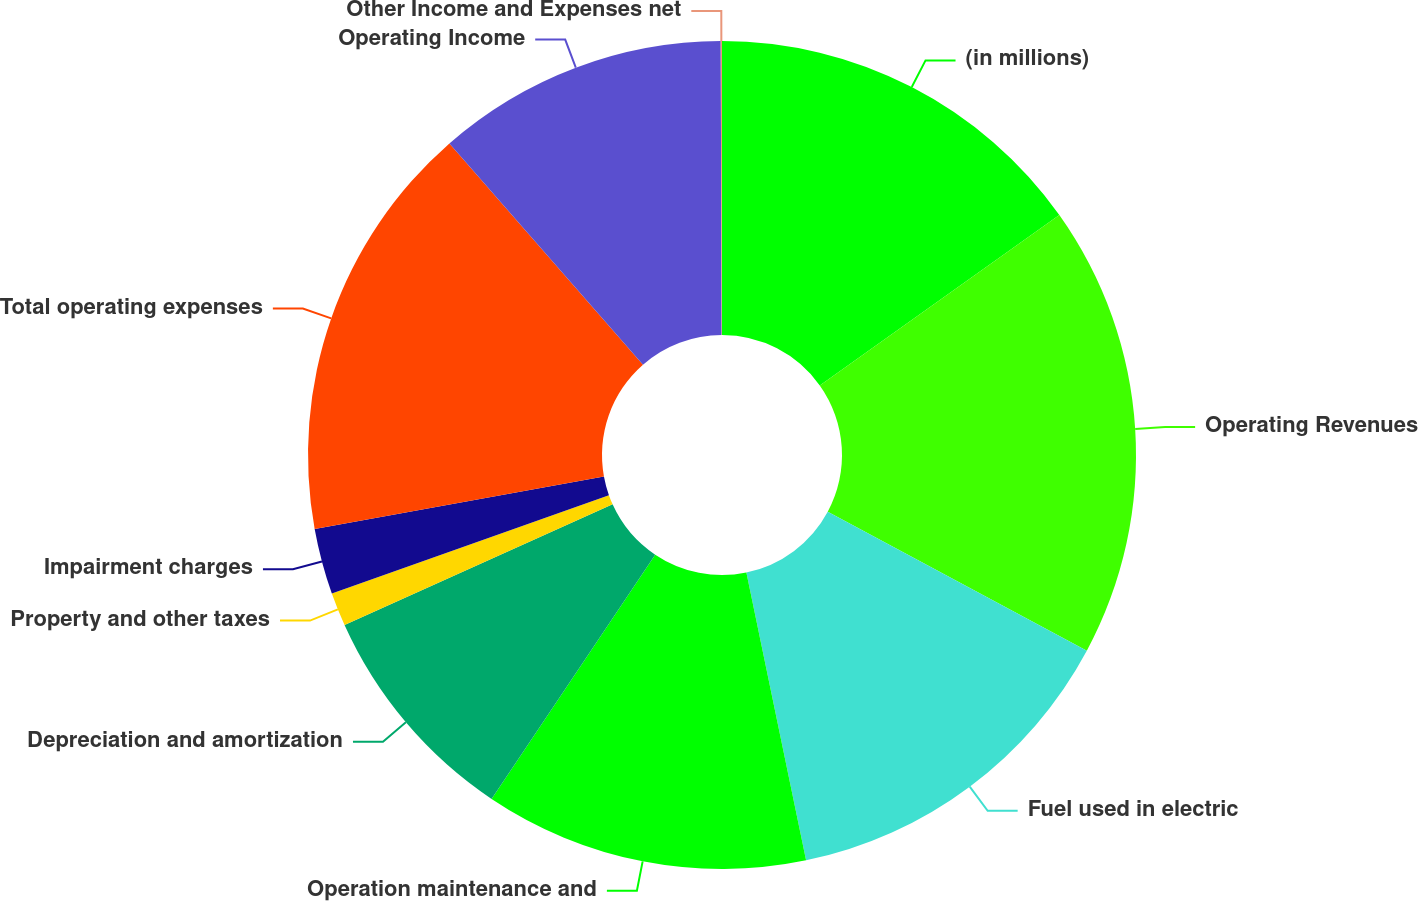Convert chart to OTSL. <chart><loc_0><loc_0><loc_500><loc_500><pie_chart><fcel>(in millions)<fcel>Operating Revenues<fcel>Fuel used in electric<fcel>Operation maintenance and<fcel>Depreciation and amortization<fcel>Property and other taxes<fcel>Impairment charges<fcel>Total operating expenses<fcel>Operating Income<fcel>Other Income and Expenses net<nl><fcel>15.16%<fcel>17.68%<fcel>13.91%<fcel>12.65%<fcel>8.87%<fcel>1.31%<fcel>2.57%<fcel>16.42%<fcel>11.39%<fcel>0.05%<nl></chart> 